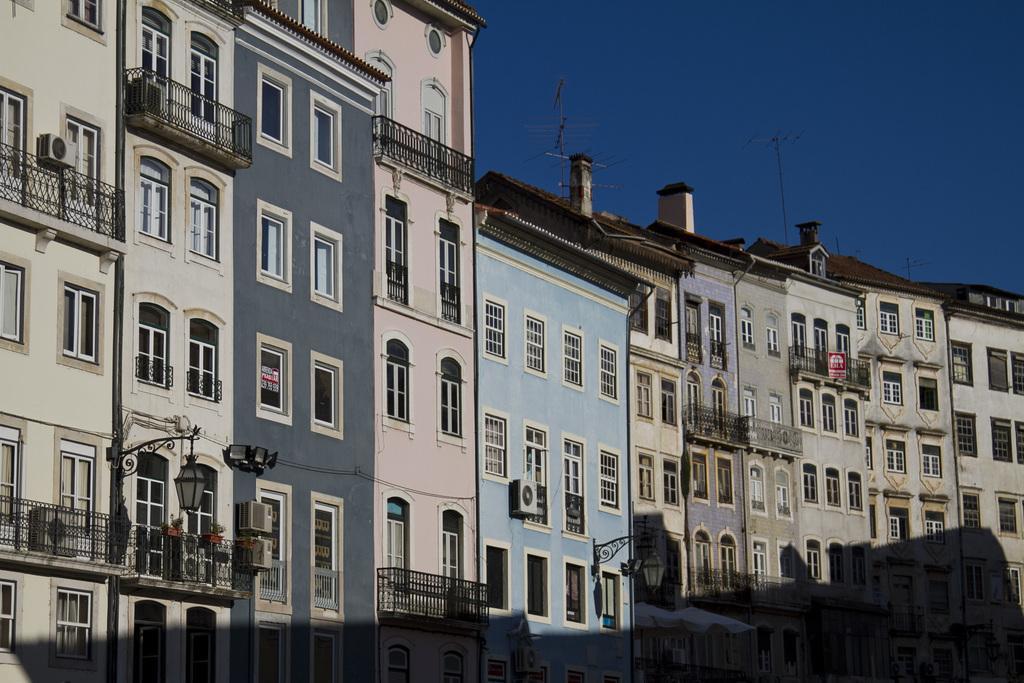Can you describe this image briefly? In the picture we can see many buildings which are side by side each other and to the buildings we can see the windows and behind the buildings we can see a part of the sky which is blue in color. 